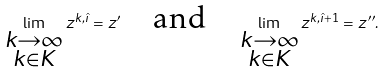Convert formula to latex. <formula><loc_0><loc_0><loc_500><loc_500>\lim _ { \substack { k \to \infty \\ k \in K } } z ^ { k , \hat { \imath } } = z ^ { \prime } \quad \text {and} \quad \lim _ { \substack { k \to \infty \\ k \in K } } z ^ { k , \hat { \imath } + 1 } = z ^ { \prime \prime } .</formula> 